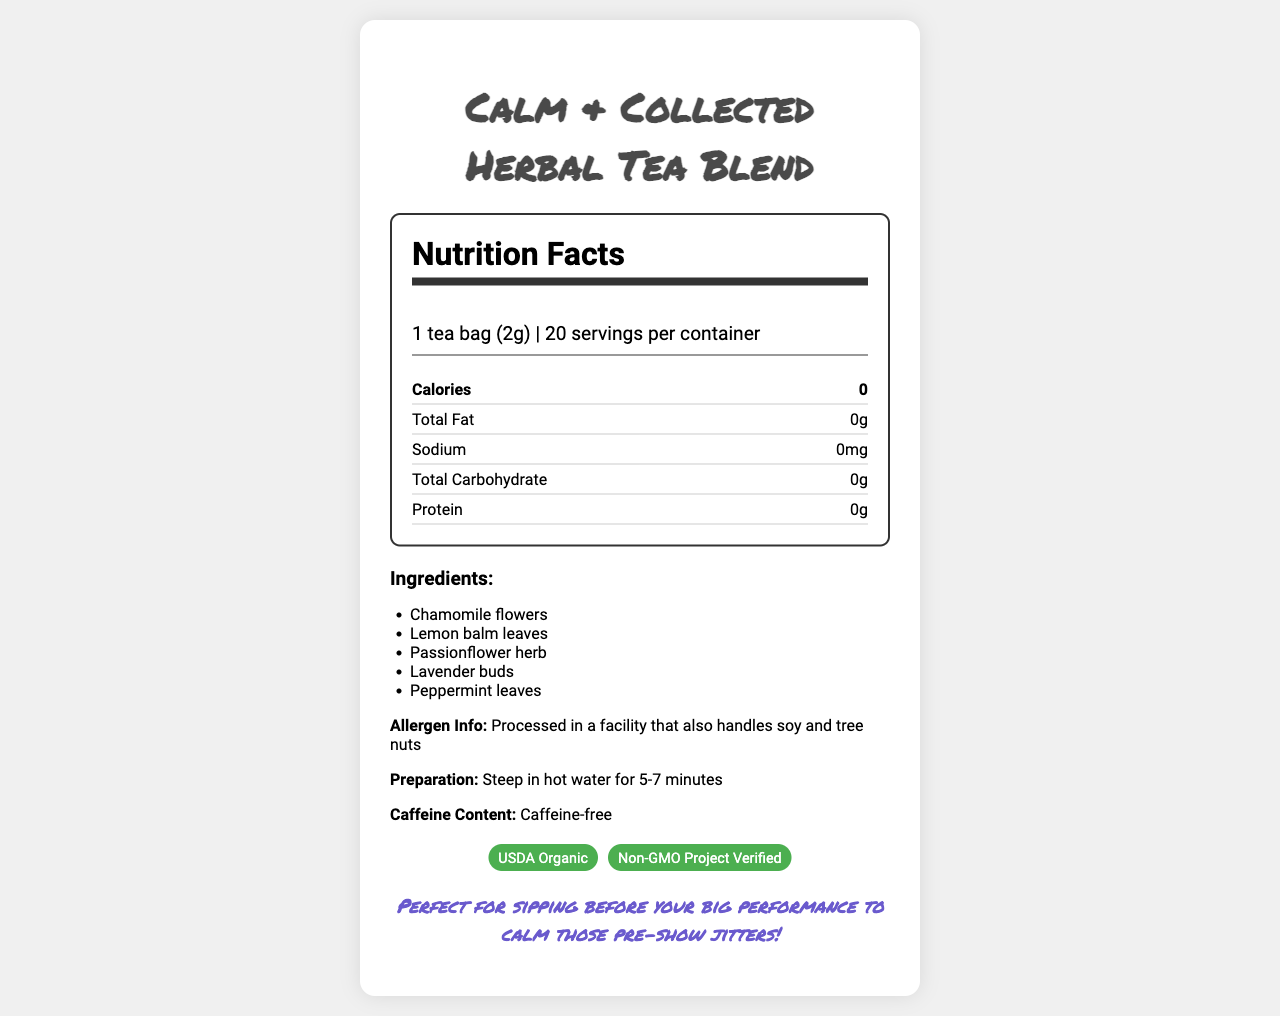what is the name of the product? The name of the product is mentioned at the top of the document.
Answer: Calm & Collected Herbal Tea Blend what is the serving size? The serving size is listed under the nutrition facts heading.
Answer: 1 tea bag (2g) how many servings are there per container? The number of servings per container is mentioned along with the serving size.
Answer: 20 how many calories are in each serving? The number of calories per serving is listed under the nutrition facts.
Answer: 0 what is the total fat content per serving? The total fat content per serving is listed in the nutrition facts section.
Answer: 0g what are the main benefits of drinking this tea? The benefits are mentioned below the preparation details.
Answer: May help reduce anxiety, Promotes relaxation, Supports mental focus which of the following ingredients is not in the tea blend? A. Chamomile flowers B. Lemon balm leaves C. Green tea D. Lavender buds Green tea is not listed in the ingredients; all other options are.
Answer: C. Green tea where should the tea be stored for best quality? A. In a refrigerator B. In a cool, dry place C. In a humid place D. In direct sunlight The storage instructions specify storing in a cool, dry place.
Answer: B. In a cool, dry place is this tea blend caffeine-free? The document mentions that the tea is caffeine-free.
Answer: Yes what certifications does this product have? The certifications are listed in the document.
Answer: USDA Organic, Non-GMO Project Verified who is the manufacturer of this tea blend? The manufacturer is mentioned at the bottom of the document.
Answer: Zen Tea Co. how long should you steep the tea bag in hot water? The steeping instructions are provided under preparation details.
Answer: 5-7 minutes does this tea contain any allergens? The allergen information is mentioned in the document.
Answer: Processed in a facility that also handles soy and tree nuts what is the expiration period for this tea blend? The expiration information is provided in the document.
Answer: Best if used within 18 months of production please summarize the main points of this document. The summary covers the main sections of the document, including nutritional facts, benefits, preparation, and storage details.
Answer: The document presents information about the Calm & Collected Herbal Tea Blend, including its serving size, nutritional content, ingredients, preparation method, allergen info, benefits, and certifications. The tea is caffeine-free and suitable for reducing anxiety, promoting relaxation, and supporting mental focus. It has certifications from USDA Organic and Non-GMO Project Verified. The product is manufactured by Zen Tea Co. and is best stored in a cool, dry place. Preparation involves steeping the tea bag in hot water for 5-7 minutes. what is the price of this product? The document does not provide any information about the price of the product.
Answer: Not enough information 